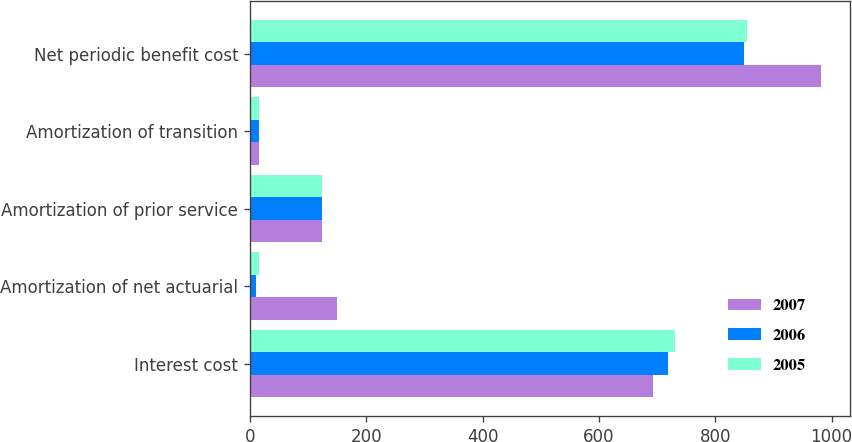Convert chart. <chart><loc_0><loc_0><loc_500><loc_500><stacked_bar_chart><ecel><fcel>Interest cost<fcel>Amortization of net actuarial<fcel>Amortization of prior service<fcel>Amortization of transition<fcel>Net periodic benefit cost<nl><fcel>2007<fcel>693<fcel>149<fcel>124<fcel>16<fcel>982<nl><fcel>2006<fcel>719<fcel>10<fcel>124<fcel>16<fcel>849<nl><fcel>2005<fcel>730<fcel>16<fcel>124<fcel>16<fcel>854<nl></chart> 